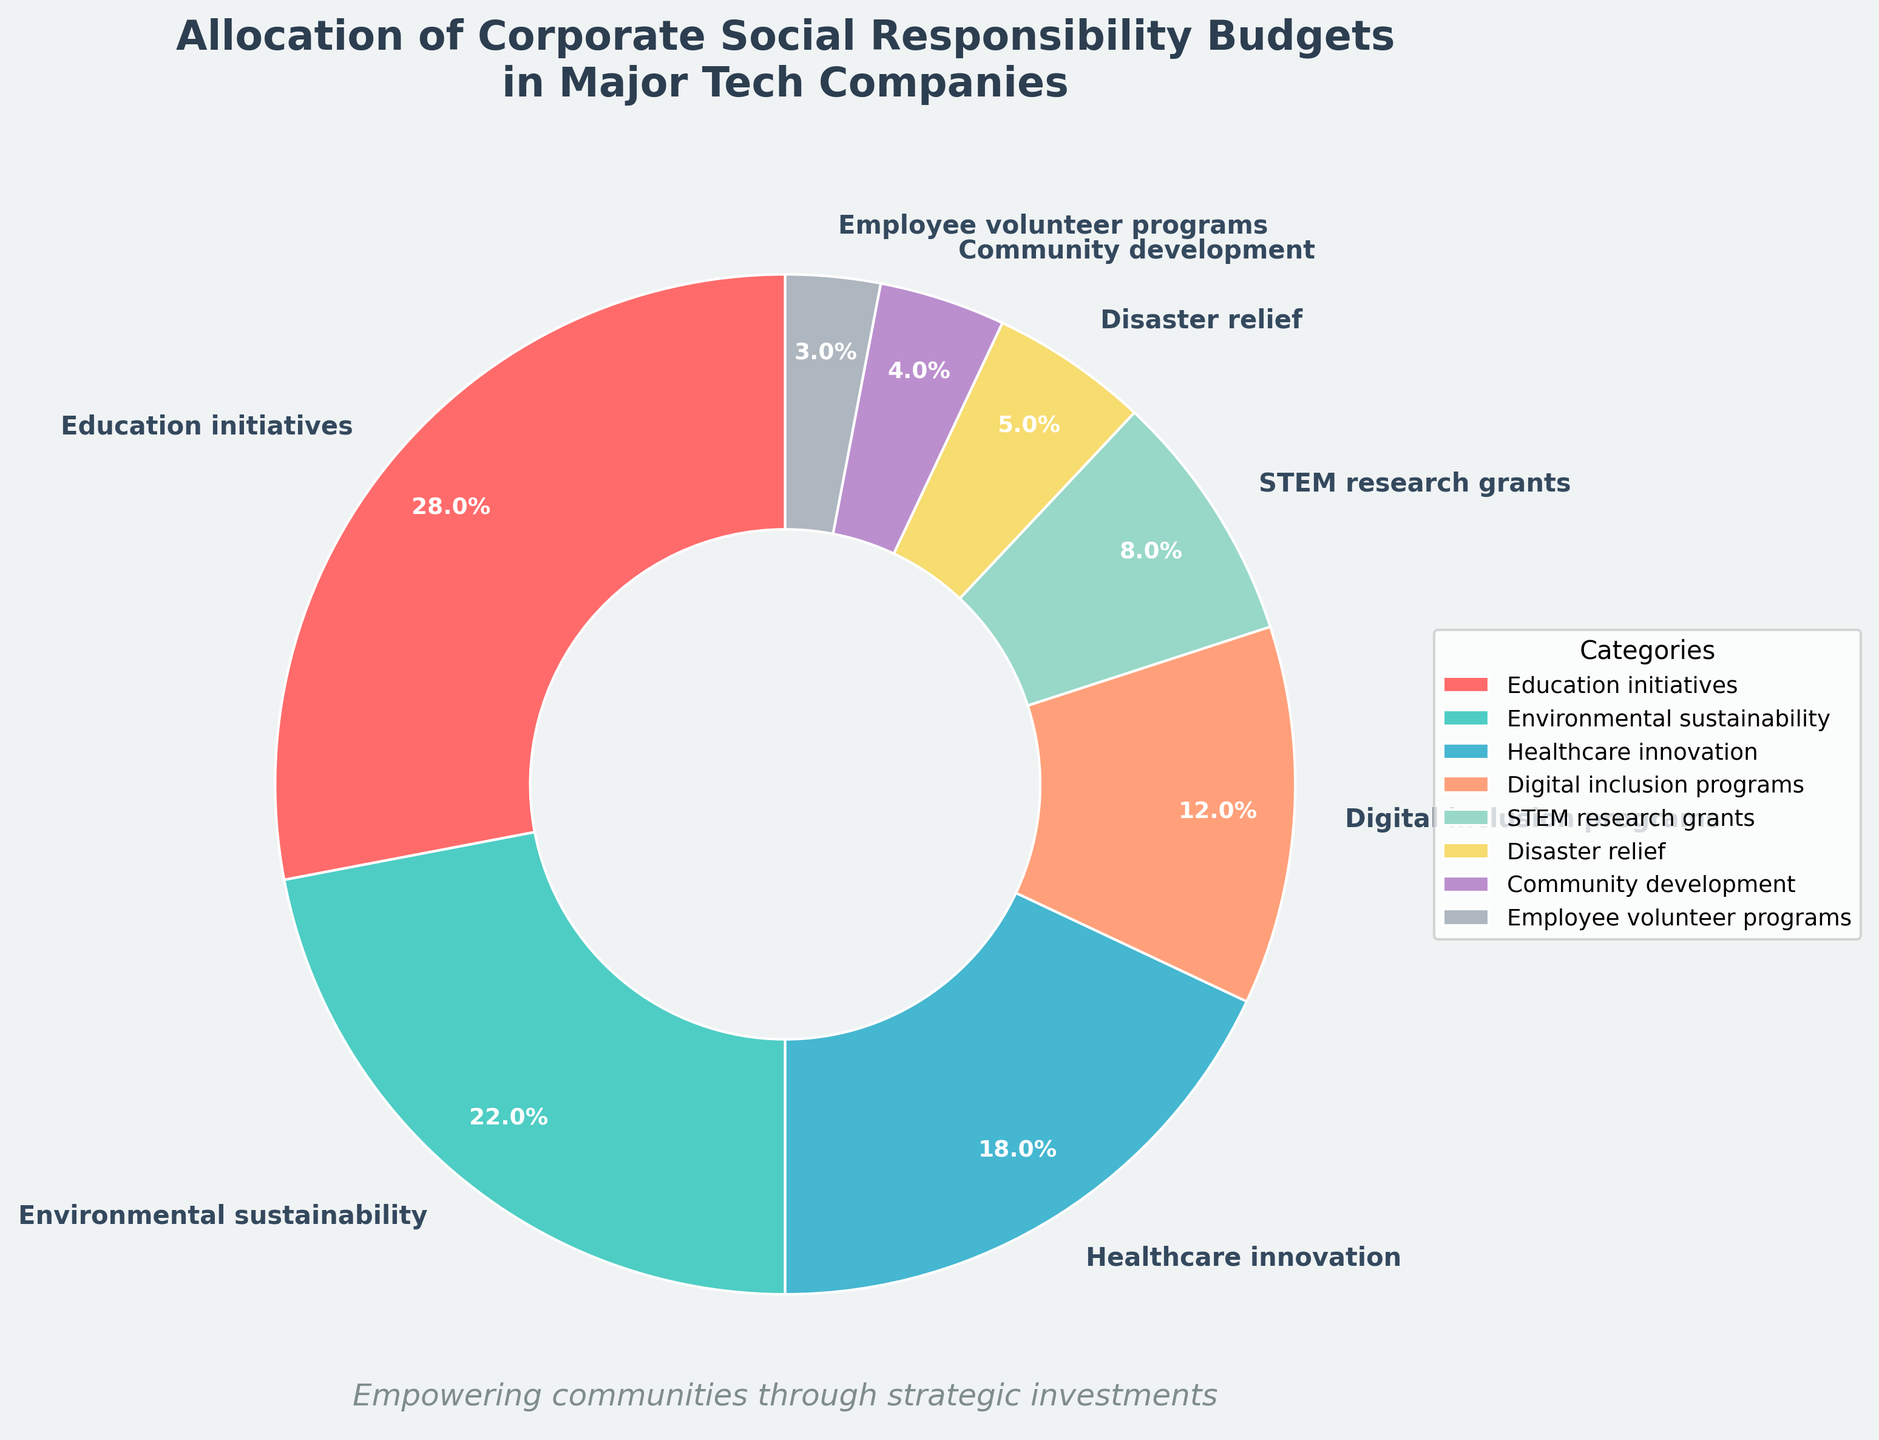What percentage of the budget is allocated to both Digital Inclusion Programs and STEM Research Grants combined? To find the combined percentage, sum the percentages for Digital Inclusion Programs (12%) and STEM Research Grants (8%). So, 12% + 8% = 20%.
Answer: 20% Which category has the smallest allocation, and what is its percentage? Look at the pie chart and identify the smallest segment, which represents Employee Volunteer Programs, with a percentage of 3%.
Answer: Employee Volunteer Programs, 3% How much more budget is allocated to Education Initiatives compared to Community Development? To find the difference, subtract Community Development's percentage (4%) from Education Initiatives' percentage (28%). So, 28% - 4% = 24%.
Answer: 24% How many categories have a budget allocation of 10% or more? Count the segments in the pie chart with percentages equal to or greater than 10%. They are Education Initiatives (28%), Environmental Sustainability (22%), Healthcare Innovation (18%), and Digital Inclusion Programs (12%). So, there are 4 categories.
Answer: 4 What is the total percentage allocated to Healthcare Innovation, Disaster Relief, and Employee Volunteer Programs combined? Add the percentages for Healthcare Innovation (18%), Disaster Relief (5%), and Employee Volunteer Programs (3%). So, 18% + 5% + 3% = 26%.
Answer: 26% Are there more funds allocated to Environmental Sustainability or Digital Inclusion Programs, and by how much? Compare the percentages for Environmental Sustainability (22%) and Digital Inclusion Programs (12%). To find the difference, subtract Digital Inclusion Programs' percentage from Environmental Sustainability's percentage, so 22% - 12% = 10%.
Answer: Environmental Sustainability, by 10% Which categories have more than 5% but less than 20% of the total CSR budget? Identify the categories that fall within this range. They are Healthcare Innovation (18%), Digital Inclusion Programs (12%), and STEM Research Grants (8%).
Answer: Healthcare Innovation, Digital Inclusion Programs, STEM Research Grants By how much does the budget for Disaster Relief differ from the budget for STEM Research Grants? To find the difference, subtract Disaster Relief's percentage (5%) from STEM Research Grants' percentage (8%). So, 8% - 5% = 3%.
Answer: 3% What are the primary colors used to represent the top three categories in terms of budget allocation? The top three categories are Education Initiatives, Environmental Sustainability, and Healthcare Innovation. Refer to the legend to identify the corresponding colors: Education Initiatives is red, Environmental Sustainability is green, and Healthcare Innovation is blue.
Answer: Red, Green, Blue Which segment represents the second smallest allocation, and what is its percentage? Identify the second smallest segment in the pie chart, which represents Community Development, with a percentage of 4%.
Answer: Community Development, 4% 